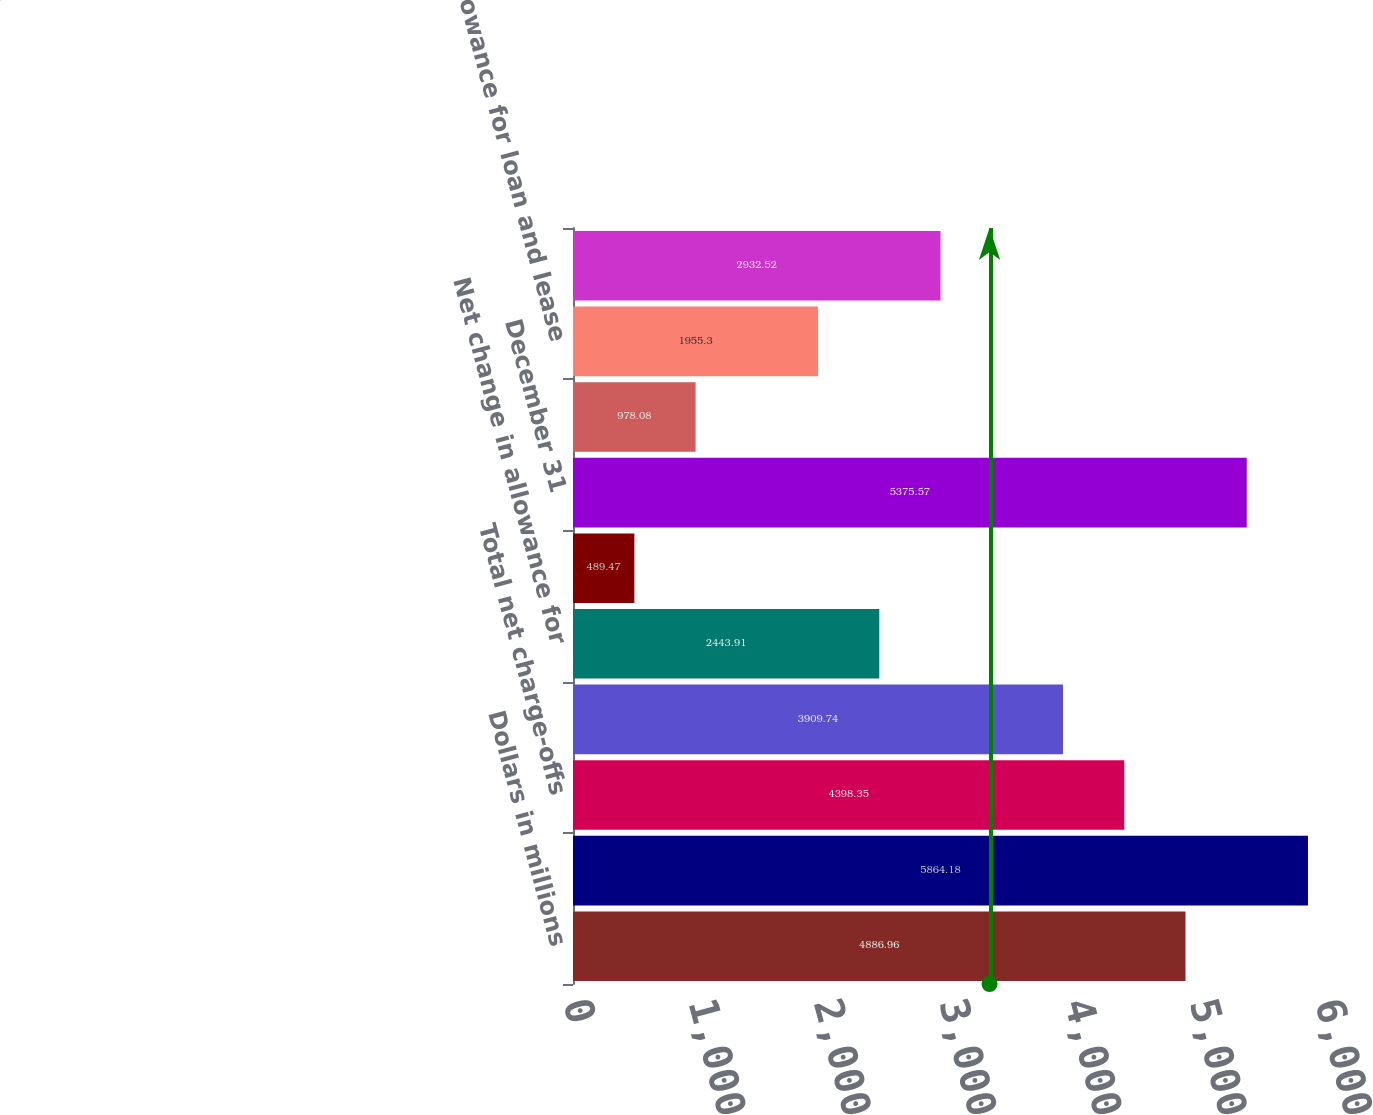Convert chart. <chart><loc_0><loc_0><loc_500><loc_500><bar_chart><fcel>Dollars in millions<fcel>January 1<fcel>Total net charge-offs<fcel>Provision for credit losses<fcel>Net change in allowance for<fcel>Other<fcel>December 31<fcel>Net charge-offs to average<fcel>Allowance for loan and lease<fcel>Commercial lending net<nl><fcel>4886.96<fcel>5864.18<fcel>4398.35<fcel>3909.74<fcel>2443.91<fcel>489.47<fcel>5375.57<fcel>978.08<fcel>1955.3<fcel>2932.52<nl></chart> 